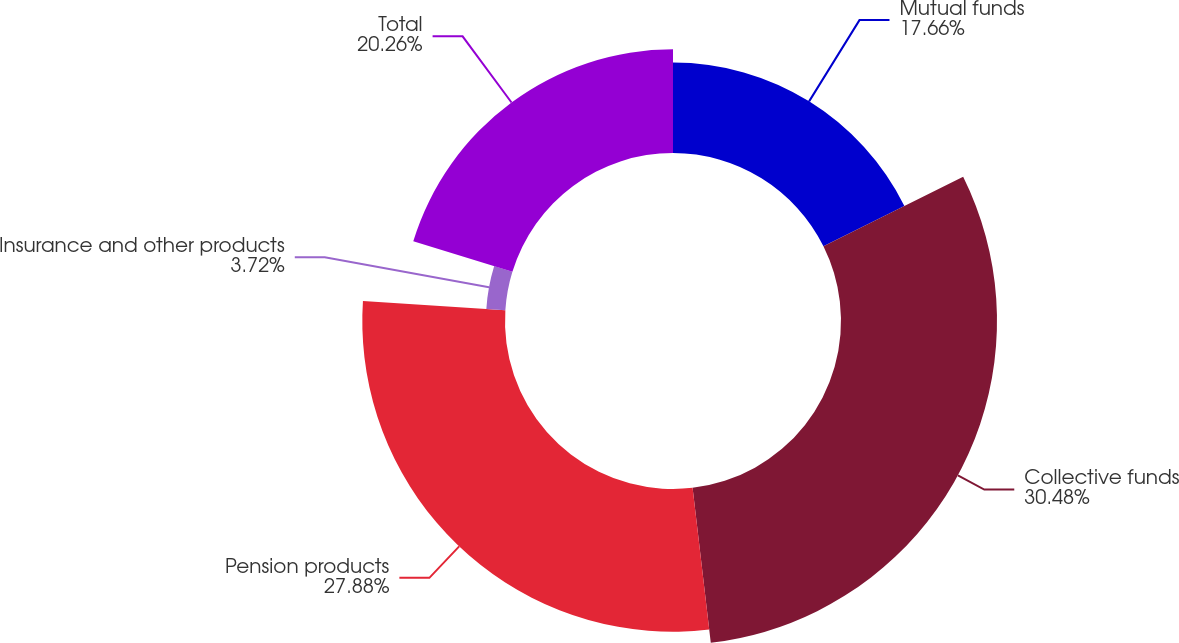Convert chart. <chart><loc_0><loc_0><loc_500><loc_500><pie_chart><fcel>Mutual funds<fcel>Collective funds<fcel>Pension products<fcel>Insurance and other products<fcel>Total<nl><fcel>17.66%<fcel>30.48%<fcel>27.88%<fcel>3.72%<fcel>20.26%<nl></chart> 